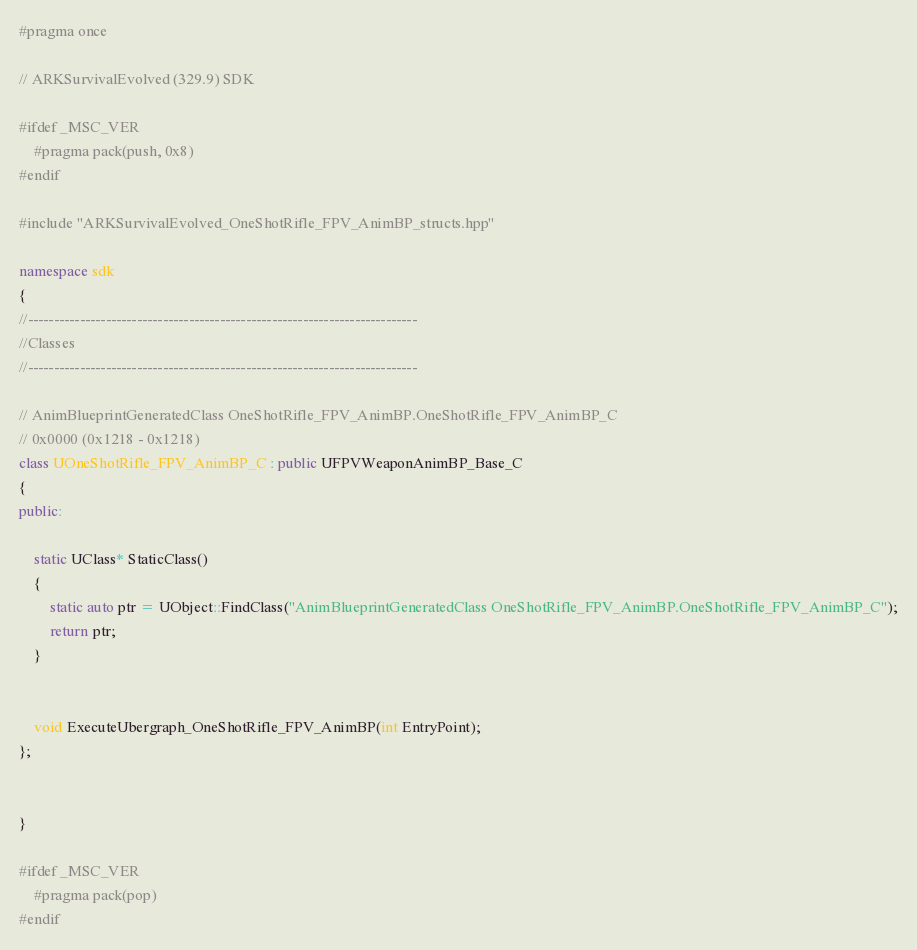<code> <loc_0><loc_0><loc_500><loc_500><_C++_>#pragma once

// ARKSurvivalEvolved (329.9) SDK

#ifdef _MSC_VER
	#pragma pack(push, 0x8)
#endif

#include "ARKSurvivalEvolved_OneShotRifle_FPV_AnimBP_structs.hpp"

namespace sdk
{
//---------------------------------------------------------------------------
//Classes
//---------------------------------------------------------------------------

// AnimBlueprintGeneratedClass OneShotRifle_FPV_AnimBP.OneShotRifle_FPV_AnimBP_C
// 0x0000 (0x1218 - 0x1218)
class UOneShotRifle_FPV_AnimBP_C : public UFPVWeaponAnimBP_Base_C
{
public:

	static UClass* StaticClass()
	{
		static auto ptr = UObject::FindClass("AnimBlueprintGeneratedClass OneShotRifle_FPV_AnimBP.OneShotRifle_FPV_AnimBP_C");
		return ptr;
	}


	void ExecuteUbergraph_OneShotRifle_FPV_AnimBP(int EntryPoint);
};


}

#ifdef _MSC_VER
	#pragma pack(pop)
#endif
</code> 